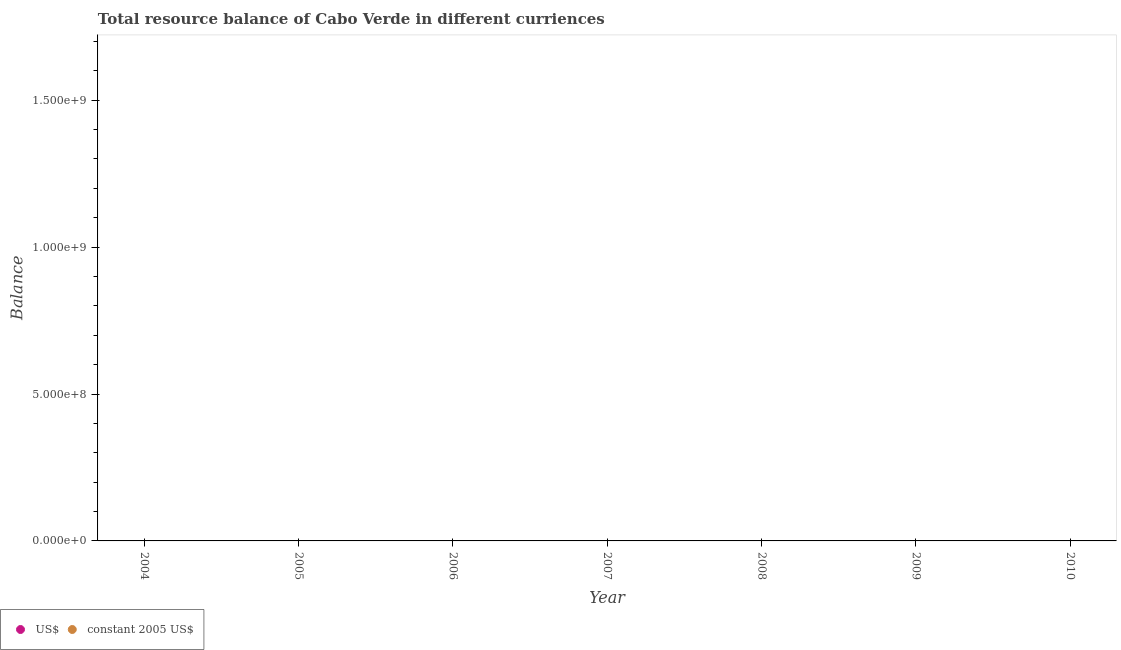How many different coloured dotlines are there?
Your response must be concise. 0. Is the number of dotlines equal to the number of legend labels?
Provide a succinct answer. No. What is the resource balance in constant us$ in 2009?
Provide a short and direct response. 0. Across all years, what is the minimum resource balance in us$?
Provide a short and direct response. 0. What is the difference between the resource balance in constant us$ in 2007 and the resource balance in us$ in 2006?
Offer a terse response. 0. What is the average resource balance in us$ per year?
Offer a very short reply. 0. In how many years, is the resource balance in us$ greater than the average resource balance in us$ taken over all years?
Provide a succinct answer. 0. Does the resource balance in constant us$ monotonically increase over the years?
Offer a terse response. No. How many dotlines are there?
Ensure brevity in your answer.  0. Where does the legend appear in the graph?
Make the answer very short. Bottom left. How many legend labels are there?
Your answer should be very brief. 2. How are the legend labels stacked?
Offer a very short reply. Horizontal. What is the title of the graph?
Offer a very short reply. Total resource balance of Cabo Verde in different curriences. What is the label or title of the Y-axis?
Make the answer very short. Balance. What is the Balance of constant 2005 US$ in 2004?
Make the answer very short. 0. What is the Balance of US$ in 2006?
Provide a short and direct response. 0. What is the Balance in constant 2005 US$ in 2006?
Your response must be concise. 0. What is the Balance in constant 2005 US$ in 2007?
Provide a succinct answer. 0. What is the Balance of US$ in 2010?
Offer a very short reply. 0. What is the Balance in constant 2005 US$ in 2010?
Offer a very short reply. 0. What is the average Balance in US$ per year?
Your response must be concise. 0. 